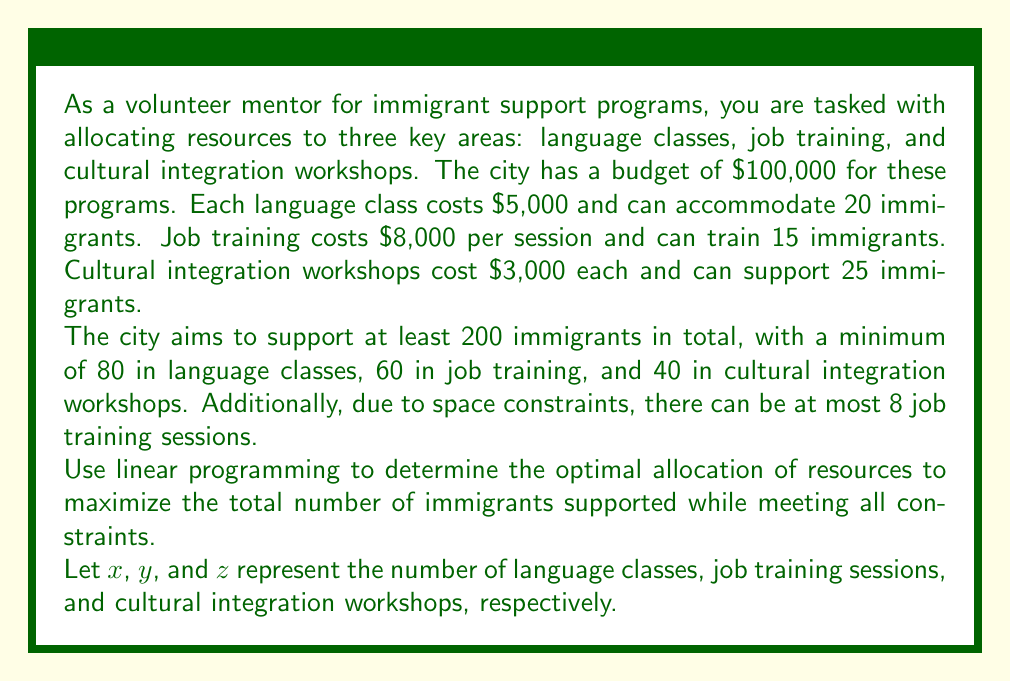Can you answer this question? To solve this linear programming problem, we'll follow these steps:

1. Define the objective function
2. Identify the constraints
3. Set up the linear programming model
4. Solve the model using the simplex method or a graphical approach

Step 1: Define the objective function

Our goal is to maximize the total number of immigrants supported:
$$\text{Maximize: } 20x + 15y + 25z$$

Step 2: Identify the constraints

Budget constraint:
$$5000x + 8000y + 3000z \leq 100000$$

Minimum total immigrants:
$$20x + 15y + 25z \geq 200$$

Minimum immigrants per program:
$$20x \geq 80$$
$$15y \geq 60$$
$$25z \geq 40$$

Maximum job training sessions:
$$y \leq 8$$

Non-negativity constraints:
$$x, y, z \geq 0$$

Step 3: Set up the linear programming model

$$\begin{align*}
\text{Maximize: } & 20x + 15y + 25z \\
\text{Subject to: } & 5000x + 8000y + 3000z \leq 100000 \\
& 20x + 15y + 25z \geq 200 \\
& 20x \geq 80 \\
& 15y \geq 60 \\
& 25z \geq 40 \\
& y \leq 8 \\
& x, y, z \geq 0
\end{align*}$$

Step 4: Solve the model

Using a linear programming solver or graphical method, we find the optimal solution:

$$x = 4, y = 4, z = 8$$

This means:
- 4 language classes
- 4 job training sessions
- 8 cultural integration workshops

We can verify that this solution satisfies all constraints:

Budget: $5000(4) + 8000(4) + 3000(8) = 20000 + 32000 + 24000 = 76000 \leq 100000$
Total immigrants: $20(4) + 15(4) + 25(8) = 80 + 60 + 200 = 340 \geq 200$
Language classes: $20(4) = 80 \geq 80$
Job training: $15(4) = 60 \geq 60$
Cultural integration: $25(8) = 200 \geq 40$
Job training sessions: $4 \leq 8$

The total number of immigrants supported is 340.
Answer: The optimal resource allocation is:
- 4 language classes
- 4 job training sessions
- 8 cultural integration workshops

This allocation supports a total of 340 immigrants. 